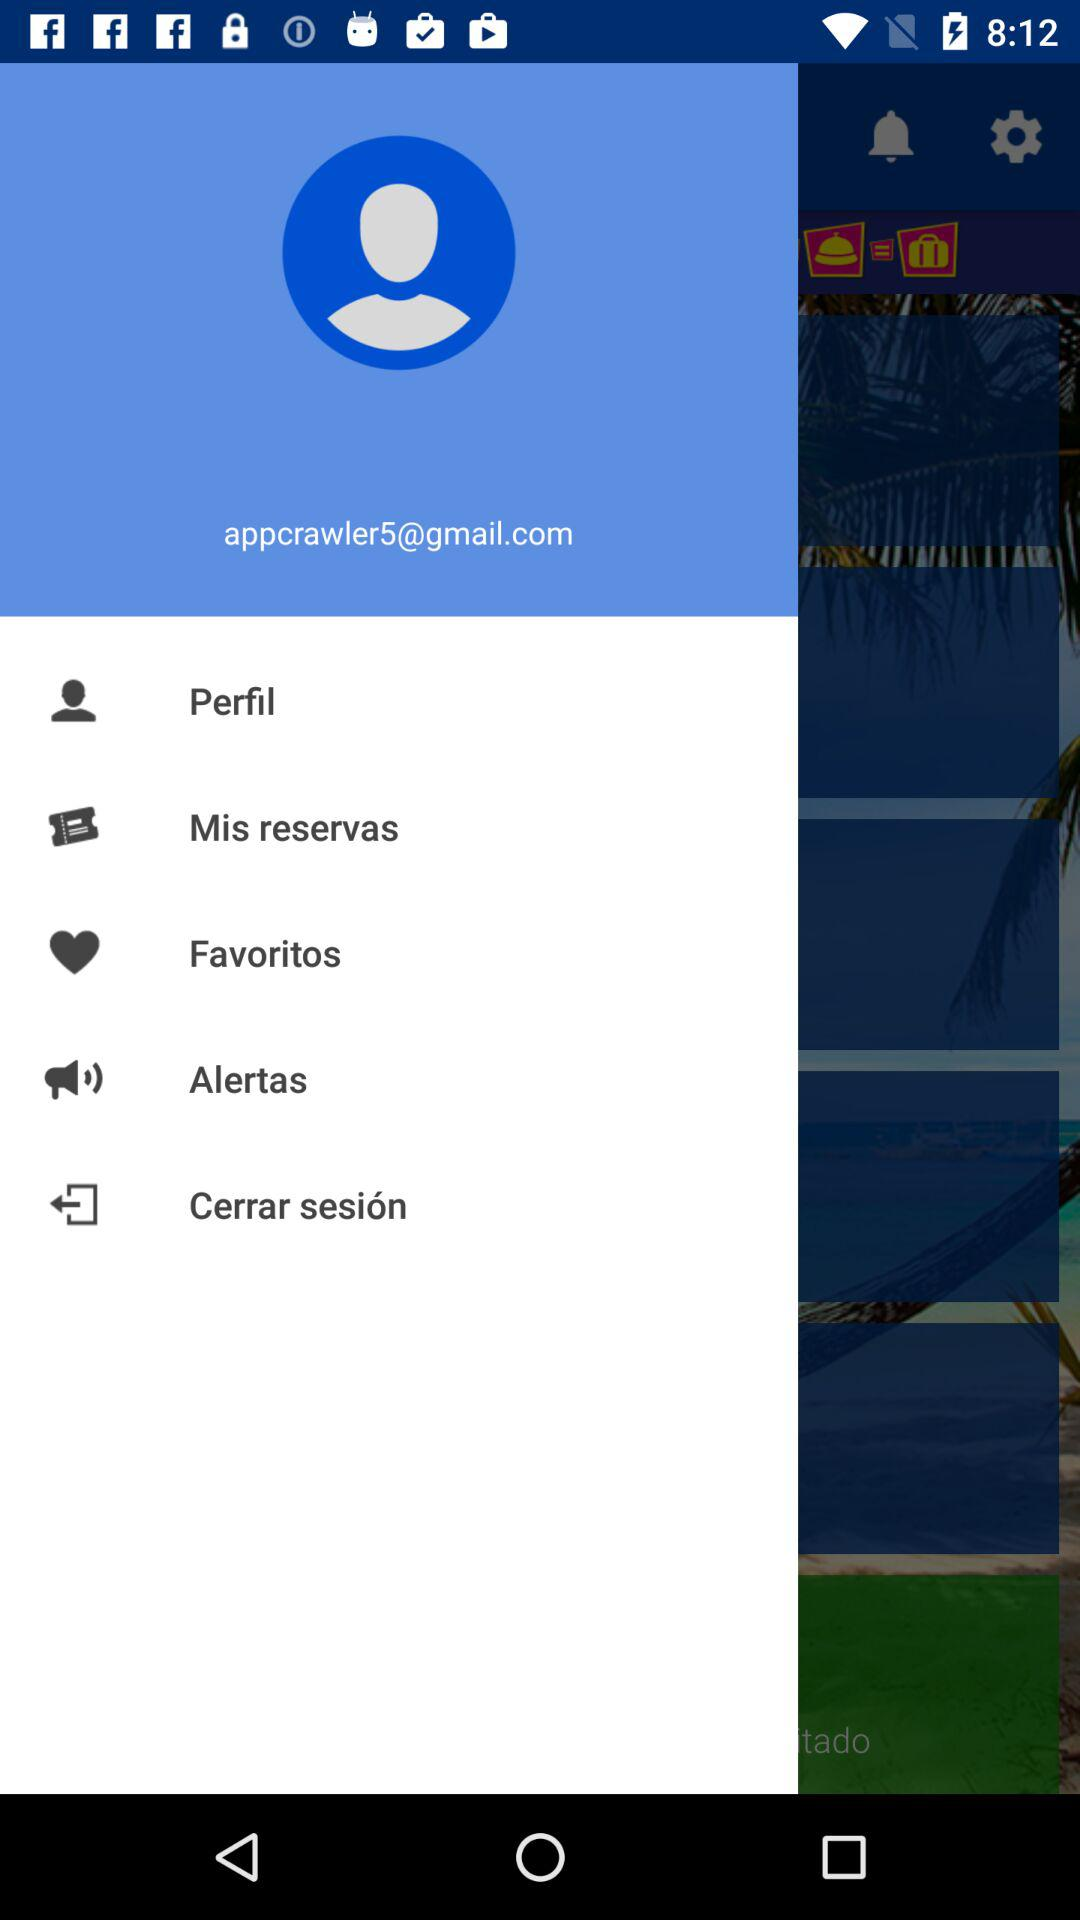What is the email address? The email address is appcrawler5@gmail.com. 